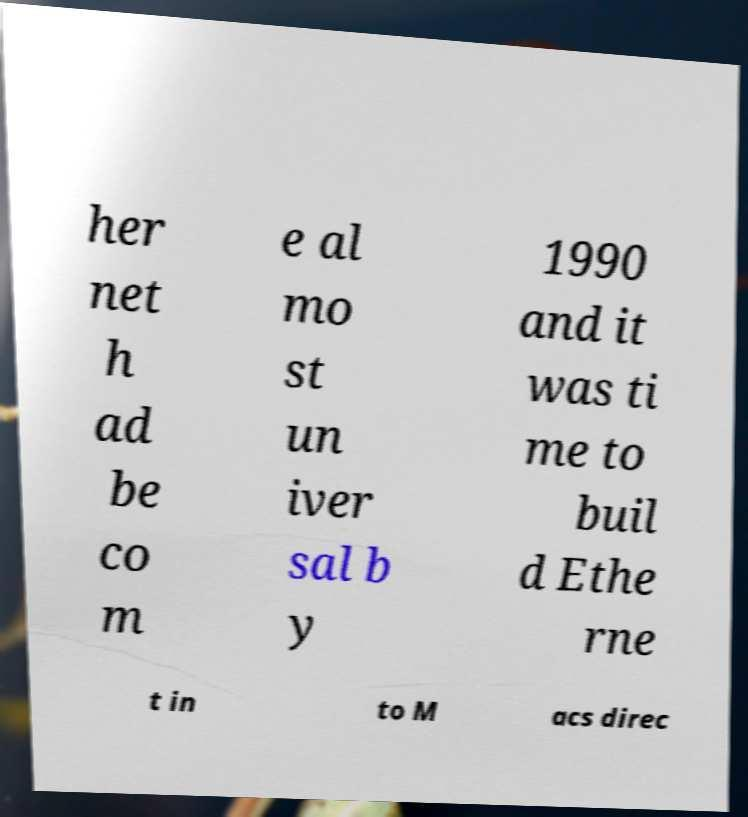I need the written content from this picture converted into text. Can you do that? her net h ad be co m e al mo st un iver sal b y 1990 and it was ti me to buil d Ethe rne t in to M acs direc 